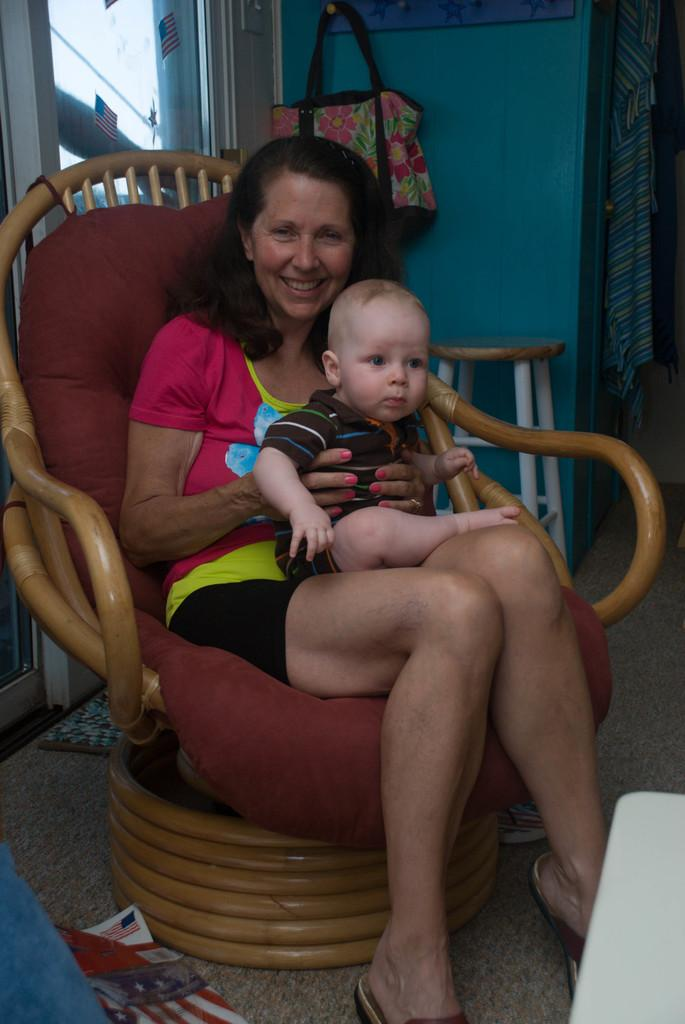What is the woman in the image doing? The woman is sitting on a chair in the image. What is the woman holding in the image? The woman is holding a baby. What other piece of furniture can be seen in the image? There is a stool at the back of the image. What else is present in the image besides the woman and the baby? There is a bag on a hanger in the image. What type of coat is the father wearing in the image? There is no father present in the image, nor is there a coat visible. 